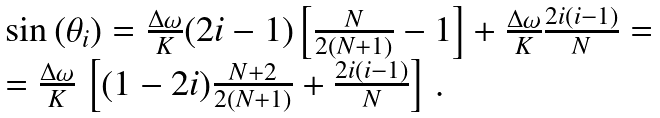Convert formula to latex. <formula><loc_0><loc_0><loc_500><loc_500>\begin{array} { l } \sin { ( \theta _ { i } ) } = \frac { \Delta \omega } { K } ( 2 i - 1 ) \left [ \frac { N } { 2 ( N + 1 ) } - 1 \right ] + \frac { \Delta \omega } { K } \frac { 2 i ( i - 1 ) } { N } = \\ = \frac { \Delta \omega } { K } \, \left [ ( 1 - 2 i ) \frac { N + 2 } { 2 ( N + 1 ) } + \frac { 2 i ( i - 1 ) } { N } \right ] \, . \end{array}</formula> 